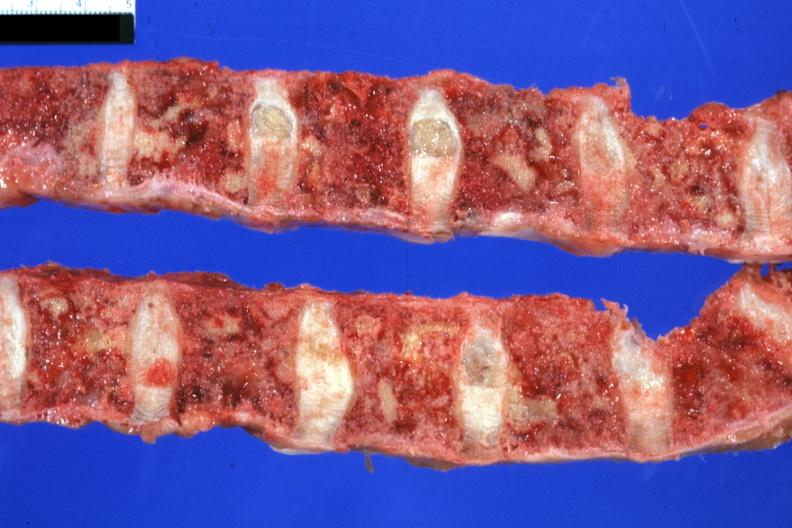what does this image show?
Answer the question using a single word or phrase. Vertebral column with multiple lesions easily seen colon primary 